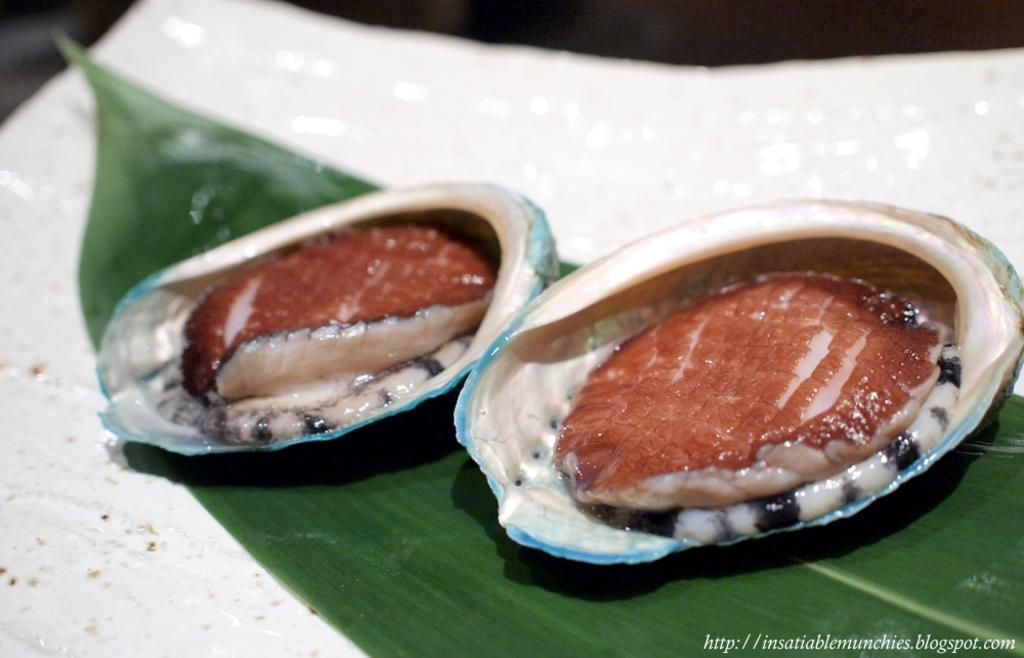What is present on the leaf in the image? There are food items on the leaf in the image. What can be seen in the background of the image? The background of the image has white and black colors. What type of summer activity is the father participating in with his step-children in the image? There is no reference to a father, step-children, or summer activity in the image; it only features a leaf with food items and a background with white and black colors. 